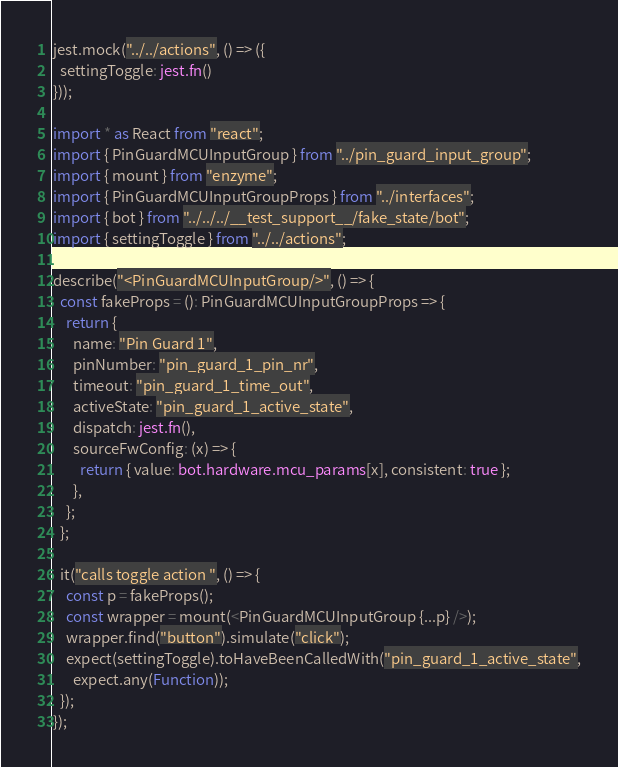Convert code to text. <code><loc_0><loc_0><loc_500><loc_500><_TypeScript_>jest.mock("../../actions", () => ({
  settingToggle: jest.fn()
}));

import * as React from "react";
import { PinGuardMCUInputGroup } from "../pin_guard_input_group";
import { mount } from "enzyme";
import { PinGuardMCUInputGroupProps } from "../interfaces";
import { bot } from "../../../__test_support__/fake_state/bot";
import { settingToggle } from "../../actions";

describe("<PinGuardMCUInputGroup/>", () => {
  const fakeProps = (): PinGuardMCUInputGroupProps => {
    return {
      name: "Pin Guard 1",
      pinNumber: "pin_guard_1_pin_nr",
      timeout: "pin_guard_1_time_out",
      activeState: "pin_guard_1_active_state",
      dispatch: jest.fn(),
      sourceFwConfig: (x) => {
        return { value: bot.hardware.mcu_params[x], consistent: true };
      },
    };
  };

  it("calls toggle action ", () => {
    const p = fakeProps();
    const wrapper = mount(<PinGuardMCUInputGroup {...p} />);
    wrapper.find("button").simulate("click");
    expect(settingToggle).toHaveBeenCalledWith("pin_guard_1_active_state",
      expect.any(Function));
  });
});
</code> 